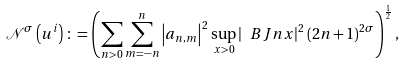<formula> <loc_0><loc_0><loc_500><loc_500>\mathcal { N } ^ { \sigma } \left ( u ^ { i } \right ) \colon = \left ( \sum _ { n > 0 } \sum _ { m = - n } ^ { n } \left | a _ { n , m } \right | ^ { 2 } \sup _ { x > 0 } \left | \ B J { n } { x } \right | ^ { 2 } ( 2 n + 1 ) ^ { 2 \sigma } \right ) ^ { \frac { 1 } { 2 } } ,</formula> 